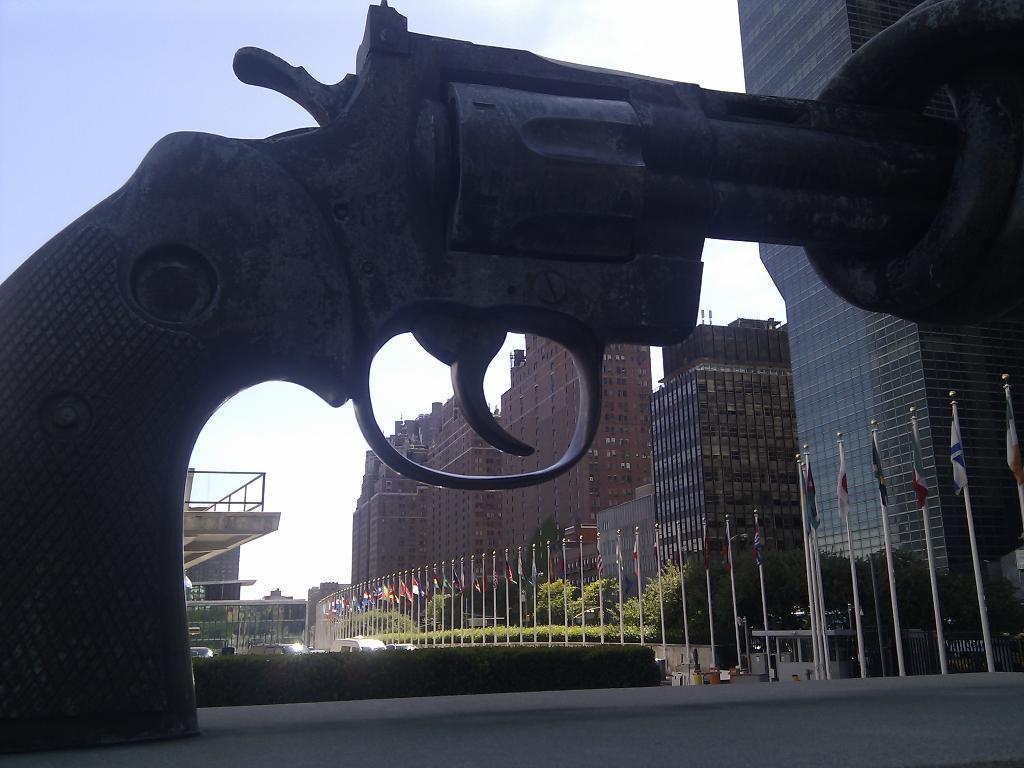How would you summarize this image in a sentence or two? This image is clicked on the road. In the foreground there is a sculpture of a gun. Behind it there are hedges. In the background there are building. There are flags to the poles in front of the buildings. There are trees and vehicles in the image. At the top there is the sky. 